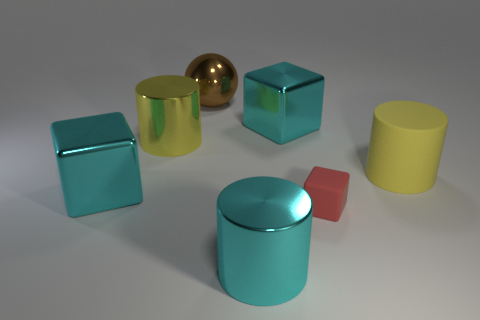Is there anything else that is the same size as the red object? Upon closer inspection, it appears that none of the other objects present share the exact dimensions as the red cube; however, size comparison in images can be tricky without a common reference point. 